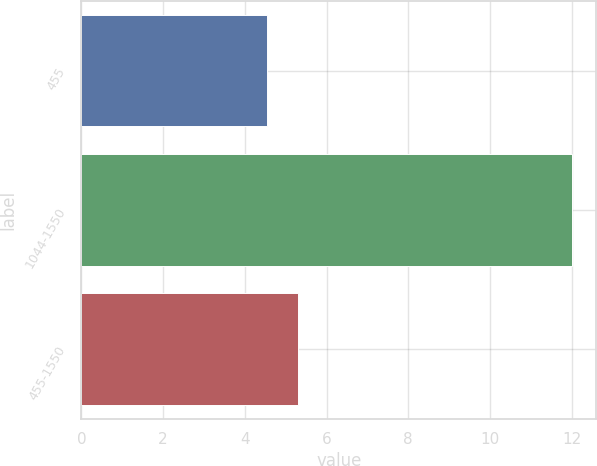Convert chart. <chart><loc_0><loc_0><loc_500><loc_500><bar_chart><fcel>455<fcel>1044-1550<fcel>455-1550<nl><fcel>4.55<fcel>12<fcel>5.29<nl></chart> 